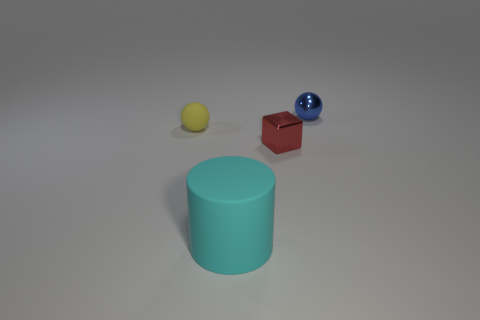What number of objects are either big matte objects or blue metallic objects behind the yellow matte ball?
Your response must be concise. 2. Are there fewer blue spheres than balls?
Offer a very short reply. Yes. There is a sphere right of the sphere that is left of the blue thing; what is its color?
Your answer should be compact. Blue. What is the material of the other object that is the same shape as the small blue object?
Offer a very short reply. Rubber. What number of metal things are small yellow spheres or small purple things?
Your answer should be very brief. 0. Are the ball that is on the left side of the big thing and the ball that is on the right side of the cyan matte object made of the same material?
Offer a terse response. No. Is there a small brown metal sphere?
Provide a succinct answer. No. Is the shape of the tiny object left of the large cyan matte cylinder the same as the rubber thing that is in front of the tiny yellow matte sphere?
Ensure brevity in your answer.  No. Is there a cyan cylinder made of the same material as the blue sphere?
Your answer should be compact. No. Does the cylinder in front of the small metallic sphere have the same material as the cube?
Your answer should be compact. No. 